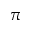<formula> <loc_0><loc_0><loc_500><loc_500>\pi</formula> 